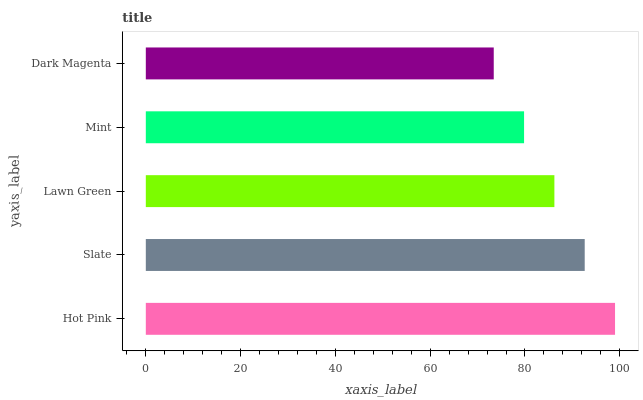Is Dark Magenta the minimum?
Answer yes or no. Yes. Is Hot Pink the maximum?
Answer yes or no. Yes. Is Slate the minimum?
Answer yes or no. No. Is Slate the maximum?
Answer yes or no. No. Is Hot Pink greater than Slate?
Answer yes or no. Yes. Is Slate less than Hot Pink?
Answer yes or no. Yes. Is Slate greater than Hot Pink?
Answer yes or no. No. Is Hot Pink less than Slate?
Answer yes or no. No. Is Lawn Green the high median?
Answer yes or no. Yes. Is Lawn Green the low median?
Answer yes or no. Yes. Is Hot Pink the high median?
Answer yes or no. No. Is Slate the low median?
Answer yes or no. No. 